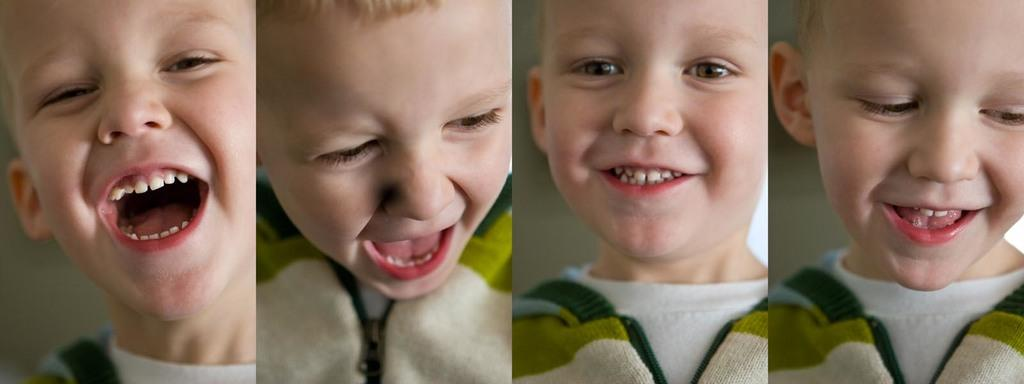What type of artwork is present in the image? The image contains a collage. What subject is featured in the collage? The collage features the same boy. How does the boy's appearance change throughout the collage? The boy has different expressions in each part of the collage. What type of cable can be seen in the image? There is no cable present in the image; it features a collage of the same boy with different expressions. Is the boy in danger of sinking into quicksand in the image? There is no quicksand present in the image; it is a collage of the boy with different expressions. 